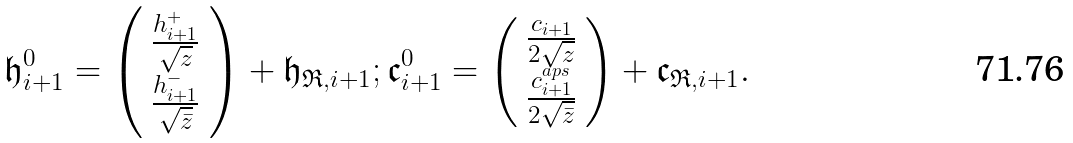<formula> <loc_0><loc_0><loc_500><loc_500>\mathfrak { h } ^ { 0 } _ { i + 1 } = \left ( \begin{array} { c } \frac { h _ { i + 1 } ^ { + } } { \sqrt { z } } \\ \frac { h ^ { - } _ { i + 1 } } { \sqrt { \bar { z } } } \end{array} \right ) + \mathfrak { h } _ { \mathfrak { R } , i + 1 } ; \mathfrak { c } ^ { 0 } _ { i + 1 } = \left ( \begin{array} { c } \frac { c _ { i + 1 } } { 2 \sqrt { z } } \\ \frac { c ^ { a p s } _ { i + 1 } } { 2 \sqrt { \bar { z } } } \end{array} \right ) + \mathfrak { c } _ { \mathfrak { R } , i + 1 } .</formula> 